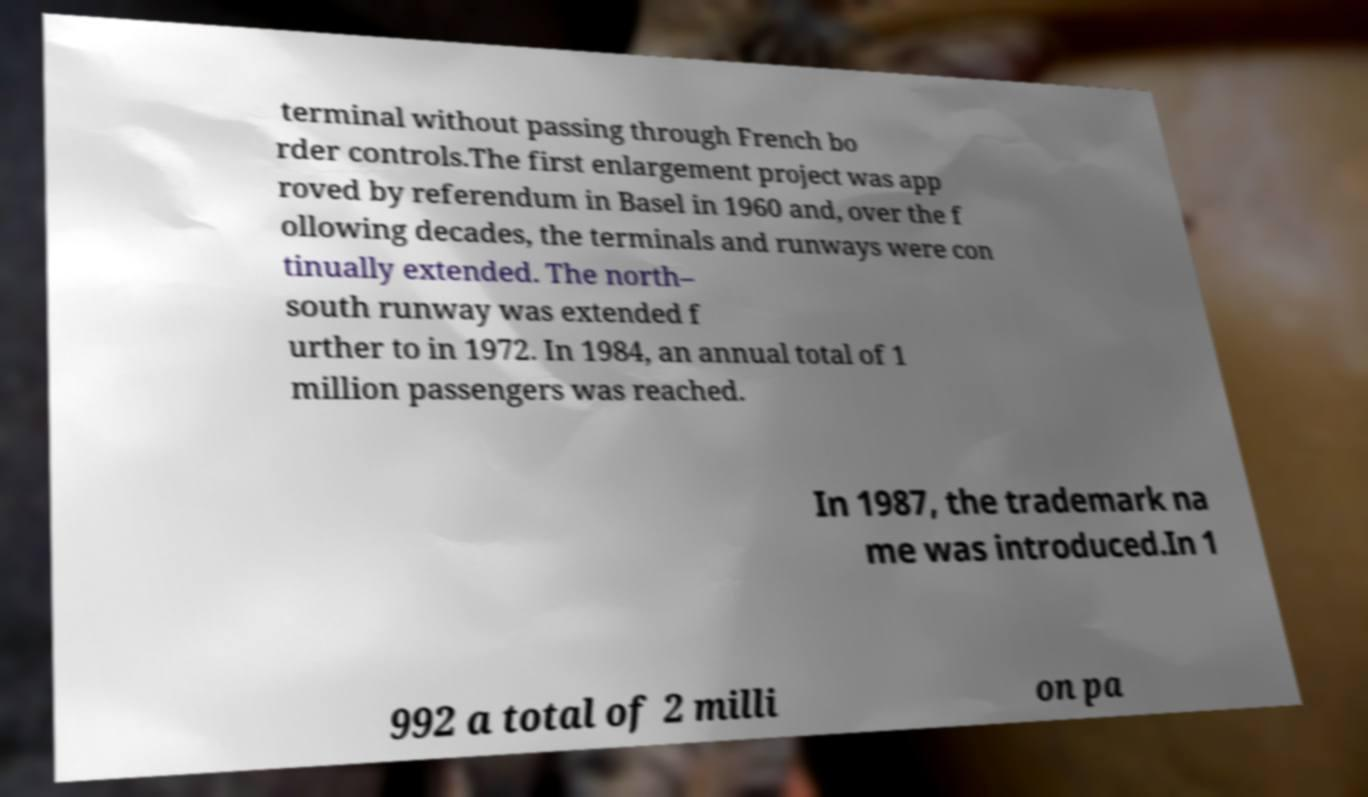Could you assist in decoding the text presented in this image and type it out clearly? terminal without passing through French bo rder controls.The first enlargement project was app roved by referendum in Basel in 1960 and, over the f ollowing decades, the terminals and runways were con tinually extended. The north– south runway was extended f urther to in 1972. In 1984, an annual total of 1 million passengers was reached. In 1987, the trademark na me was introduced.In 1 992 a total of 2 milli on pa 